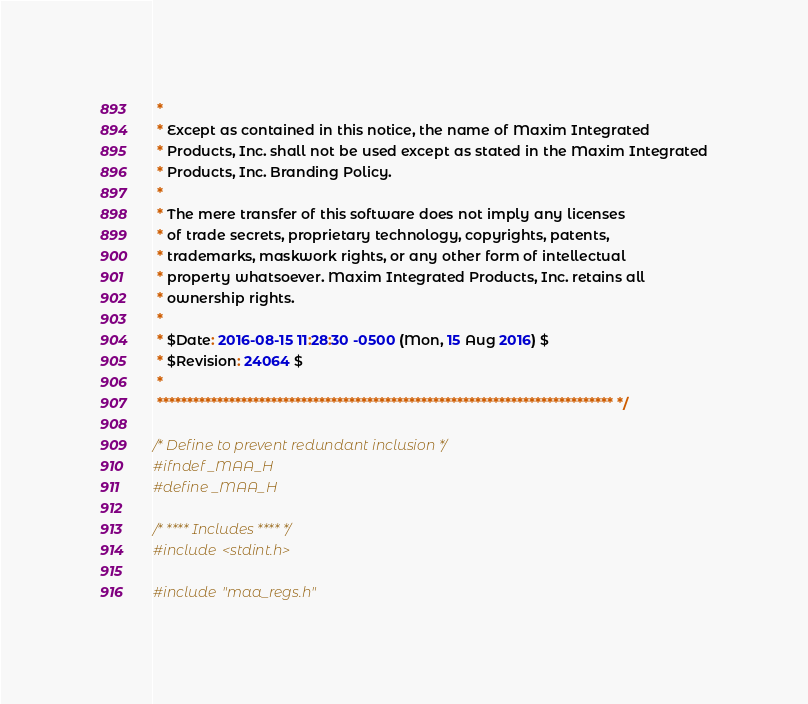<code> <loc_0><loc_0><loc_500><loc_500><_C_> *
 * Except as contained in this notice, the name of Maxim Integrated
 * Products, Inc. shall not be used except as stated in the Maxim Integrated
 * Products, Inc. Branding Policy.
 *
 * The mere transfer of this software does not imply any licenses
 * of trade secrets, proprietary technology, copyrights, patents,
 * trademarks, maskwork rights, or any other form of intellectual
 * property whatsoever. Maxim Integrated Products, Inc. retains all
 * ownership rights.
 *
 * $Date: 2016-08-15 11:28:30 -0500 (Mon, 15 Aug 2016) $
 * $Revision: 24064 $
 *
 **************************************************************************** */

/* Define to prevent redundant inclusion */
#ifndef _MAA_H
#define _MAA_H

/* **** Includes **** */
#include <stdint.h>

#include "maa_regs.h"
</code> 